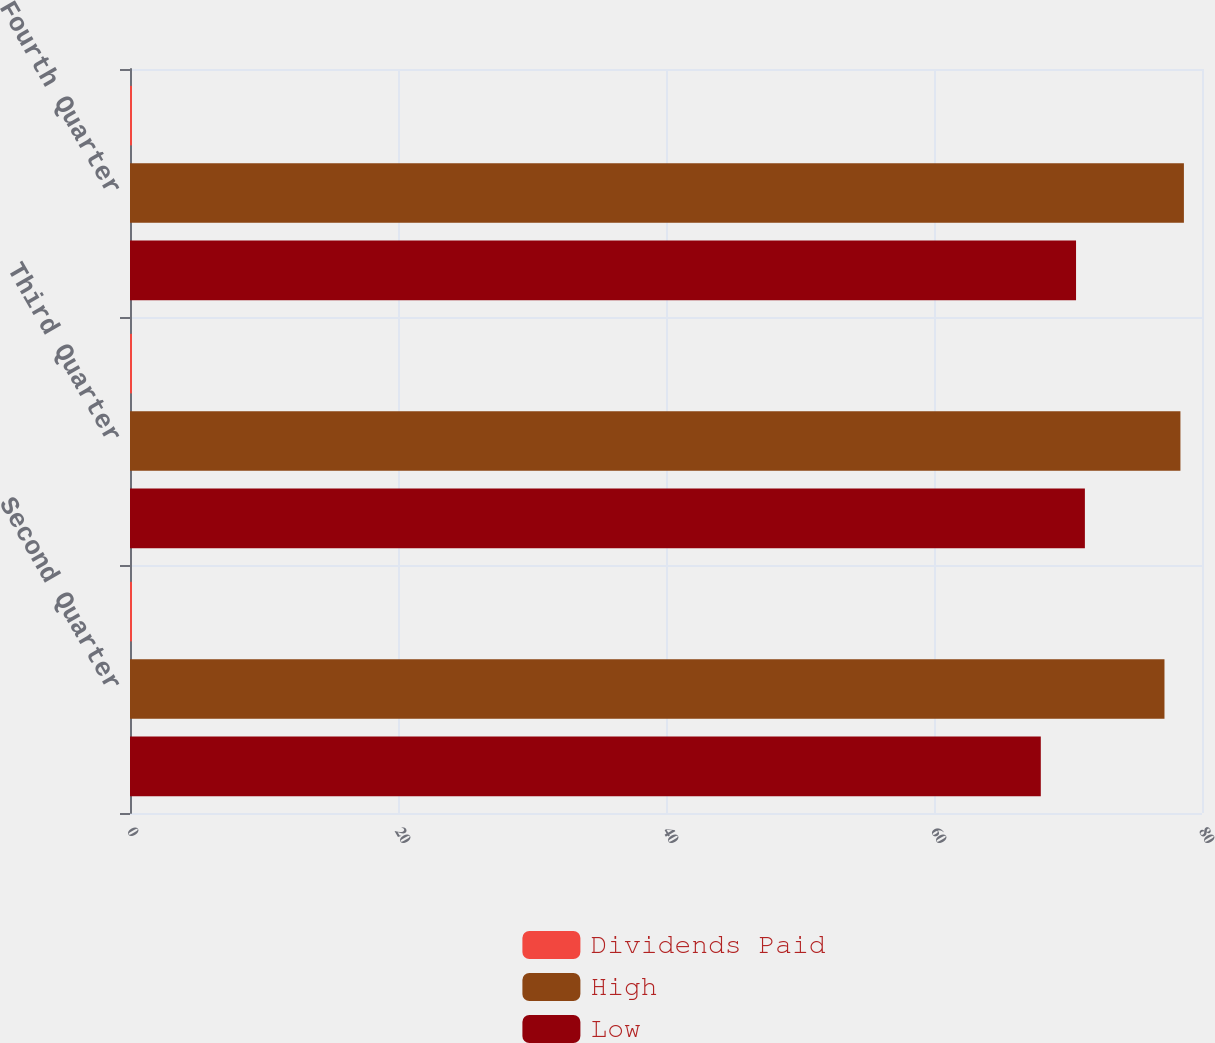<chart> <loc_0><loc_0><loc_500><loc_500><stacked_bar_chart><ecel><fcel>Second Quarter<fcel>Third Quarter<fcel>Fourth Quarter<nl><fcel>Dividends Paid<fcel>0.15<fcel>0.15<fcel>0.15<nl><fcel>High<fcel>77.2<fcel>78.39<fcel>78.65<nl><fcel>Low<fcel>67.97<fcel>71.26<fcel>70.6<nl></chart> 